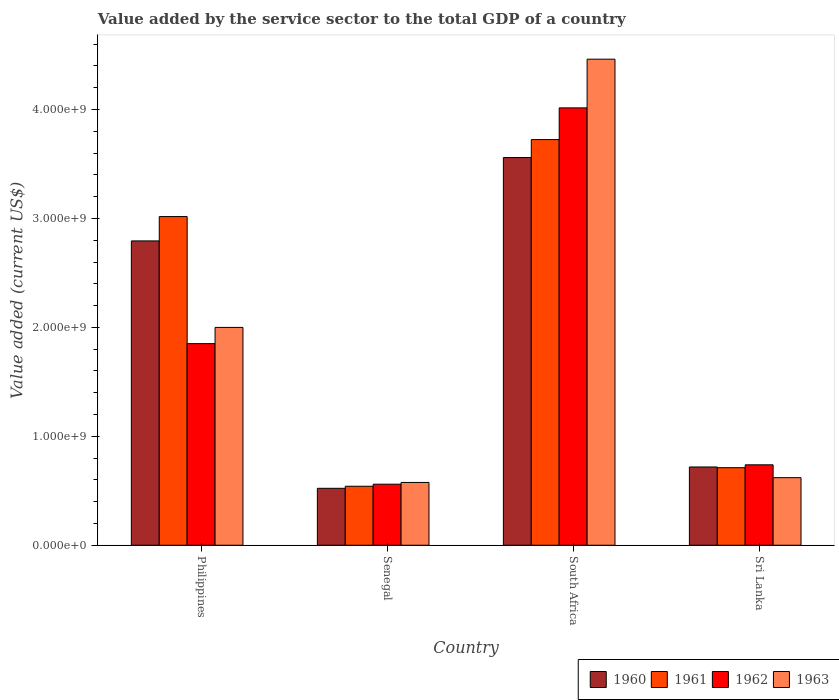How many different coloured bars are there?
Your response must be concise. 4. How many groups of bars are there?
Provide a short and direct response. 4. Are the number of bars on each tick of the X-axis equal?
Offer a very short reply. Yes. How many bars are there on the 3rd tick from the left?
Make the answer very short. 4. How many bars are there on the 4th tick from the right?
Offer a terse response. 4. What is the label of the 2nd group of bars from the left?
Provide a succinct answer. Senegal. What is the value added by the service sector to the total GDP in 1961 in Senegal?
Provide a succinct answer. 5.42e+08. Across all countries, what is the maximum value added by the service sector to the total GDP in 1960?
Ensure brevity in your answer.  3.56e+09. Across all countries, what is the minimum value added by the service sector to the total GDP in 1963?
Ensure brevity in your answer.  5.76e+08. In which country was the value added by the service sector to the total GDP in 1961 maximum?
Offer a terse response. South Africa. In which country was the value added by the service sector to the total GDP in 1960 minimum?
Offer a very short reply. Senegal. What is the total value added by the service sector to the total GDP in 1961 in the graph?
Provide a short and direct response. 7.99e+09. What is the difference between the value added by the service sector to the total GDP in 1963 in Philippines and that in Sri Lanka?
Provide a succinct answer. 1.38e+09. What is the difference between the value added by the service sector to the total GDP in 1962 in Sri Lanka and the value added by the service sector to the total GDP in 1961 in Philippines?
Your answer should be very brief. -2.28e+09. What is the average value added by the service sector to the total GDP in 1961 per country?
Keep it short and to the point. 2.00e+09. What is the difference between the value added by the service sector to the total GDP of/in 1961 and value added by the service sector to the total GDP of/in 1960 in Sri Lanka?
Your answer should be compact. -6.51e+06. In how many countries, is the value added by the service sector to the total GDP in 1963 greater than 3000000000 US$?
Provide a short and direct response. 1. What is the ratio of the value added by the service sector to the total GDP in 1960 in Philippines to that in South Africa?
Your answer should be compact. 0.78. Is the value added by the service sector to the total GDP in 1962 in Philippines less than that in South Africa?
Offer a very short reply. Yes. Is the difference between the value added by the service sector to the total GDP in 1961 in Senegal and South Africa greater than the difference between the value added by the service sector to the total GDP in 1960 in Senegal and South Africa?
Your response must be concise. No. What is the difference between the highest and the second highest value added by the service sector to the total GDP in 1961?
Ensure brevity in your answer.  -2.31e+09. What is the difference between the highest and the lowest value added by the service sector to the total GDP in 1961?
Keep it short and to the point. 3.18e+09. In how many countries, is the value added by the service sector to the total GDP in 1963 greater than the average value added by the service sector to the total GDP in 1963 taken over all countries?
Give a very brief answer. 2. What does the 2nd bar from the right in Philippines represents?
Your answer should be compact. 1962. How many bars are there?
Ensure brevity in your answer.  16. Does the graph contain grids?
Offer a very short reply. No. How are the legend labels stacked?
Offer a terse response. Horizontal. What is the title of the graph?
Provide a succinct answer. Value added by the service sector to the total GDP of a country. Does "2000" appear as one of the legend labels in the graph?
Offer a terse response. No. What is the label or title of the X-axis?
Your answer should be very brief. Country. What is the label or title of the Y-axis?
Provide a short and direct response. Value added (current US$). What is the Value added (current US$) of 1960 in Philippines?
Offer a very short reply. 2.79e+09. What is the Value added (current US$) in 1961 in Philippines?
Ensure brevity in your answer.  3.02e+09. What is the Value added (current US$) of 1962 in Philippines?
Ensure brevity in your answer.  1.85e+09. What is the Value added (current US$) in 1963 in Philippines?
Your answer should be very brief. 2.00e+09. What is the Value added (current US$) of 1960 in Senegal?
Your response must be concise. 5.23e+08. What is the Value added (current US$) of 1961 in Senegal?
Offer a terse response. 5.42e+08. What is the Value added (current US$) of 1962 in Senegal?
Make the answer very short. 5.60e+08. What is the Value added (current US$) of 1963 in Senegal?
Your response must be concise. 5.76e+08. What is the Value added (current US$) of 1960 in South Africa?
Give a very brief answer. 3.56e+09. What is the Value added (current US$) of 1961 in South Africa?
Your answer should be very brief. 3.72e+09. What is the Value added (current US$) of 1962 in South Africa?
Your answer should be very brief. 4.01e+09. What is the Value added (current US$) in 1963 in South Africa?
Keep it short and to the point. 4.46e+09. What is the Value added (current US$) in 1960 in Sri Lanka?
Your answer should be very brief. 7.18e+08. What is the Value added (current US$) in 1961 in Sri Lanka?
Ensure brevity in your answer.  7.12e+08. What is the Value added (current US$) in 1962 in Sri Lanka?
Ensure brevity in your answer.  7.38e+08. What is the Value added (current US$) in 1963 in Sri Lanka?
Your answer should be compact. 6.20e+08. Across all countries, what is the maximum Value added (current US$) of 1960?
Offer a terse response. 3.56e+09. Across all countries, what is the maximum Value added (current US$) in 1961?
Provide a succinct answer. 3.72e+09. Across all countries, what is the maximum Value added (current US$) in 1962?
Give a very brief answer. 4.01e+09. Across all countries, what is the maximum Value added (current US$) in 1963?
Ensure brevity in your answer.  4.46e+09. Across all countries, what is the minimum Value added (current US$) in 1960?
Your answer should be very brief. 5.23e+08. Across all countries, what is the minimum Value added (current US$) of 1961?
Give a very brief answer. 5.42e+08. Across all countries, what is the minimum Value added (current US$) of 1962?
Your response must be concise. 5.60e+08. Across all countries, what is the minimum Value added (current US$) in 1963?
Offer a terse response. 5.76e+08. What is the total Value added (current US$) in 1960 in the graph?
Your answer should be very brief. 7.59e+09. What is the total Value added (current US$) of 1961 in the graph?
Provide a short and direct response. 7.99e+09. What is the total Value added (current US$) in 1962 in the graph?
Offer a very short reply. 7.16e+09. What is the total Value added (current US$) of 1963 in the graph?
Offer a very short reply. 7.66e+09. What is the difference between the Value added (current US$) of 1960 in Philippines and that in Senegal?
Provide a short and direct response. 2.27e+09. What is the difference between the Value added (current US$) of 1961 in Philippines and that in Senegal?
Keep it short and to the point. 2.48e+09. What is the difference between the Value added (current US$) of 1962 in Philippines and that in Senegal?
Make the answer very short. 1.29e+09. What is the difference between the Value added (current US$) of 1963 in Philippines and that in Senegal?
Offer a very short reply. 1.42e+09. What is the difference between the Value added (current US$) in 1960 in Philippines and that in South Africa?
Your response must be concise. -7.66e+08. What is the difference between the Value added (current US$) in 1961 in Philippines and that in South Africa?
Make the answer very short. -7.07e+08. What is the difference between the Value added (current US$) of 1962 in Philippines and that in South Africa?
Offer a very short reply. -2.16e+09. What is the difference between the Value added (current US$) of 1963 in Philippines and that in South Africa?
Ensure brevity in your answer.  -2.46e+09. What is the difference between the Value added (current US$) in 1960 in Philippines and that in Sri Lanka?
Provide a succinct answer. 2.08e+09. What is the difference between the Value added (current US$) of 1961 in Philippines and that in Sri Lanka?
Offer a terse response. 2.31e+09. What is the difference between the Value added (current US$) in 1962 in Philippines and that in Sri Lanka?
Offer a terse response. 1.11e+09. What is the difference between the Value added (current US$) of 1963 in Philippines and that in Sri Lanka?
Offer a terse response. 1.38e+09. What is the difference between the Value added (current US$) in 1960 in Senegal and that in South Africa?
Keep it short and to the point. -3.04e+09. What is the difference between the Value added (current US$) of 1961 in Senegal and that in South Africa?
Make the answer very short. -3.18e+09. What is the difference between the Value added (current US$) of 1962 in Senegal and that in South Africa?
Your answer should be compact. -3.45e+09. What is the difference between the Value added (current US$) in 1963 in Senegal and that in South Africa?
Your answer should be very brief. -3.89e+09. What is the difference between the Value added (current US$) of 1960 in Senegal and that in Sri Lanka?
Your answer should be very brief. -1.96e+08. What is the difference between the Value added (current US$) in 1961 in Senegal and that in Sri Lanka?
Your answer should be compact. -1.70e+08. What is the difference between the Value added (current US$) of 1962 in Senegal and that in Sri Lanka?
Offer a terse response. -1.78e+08. What is the difference between the Value added (current US$) in 1963 in Senegal and that in Sri Lanka?
Your answer should be very brief. -4.38e+07. What is the difference between the Value added (current US$) in 1960 in South Africa and that in Sri Lanka?
Your answer should be very brief. 2.84e+09. What is the difference between the Value added (current US$) of 1961 in South Africa and that in Sri Lanka?
Your response must be concise. 3.01e+09. What is the difference between the Value added (current US$) of 1962 in South Africa and that in Sri Lanka?
Your answer should be very brief. 3.28e+09. What is the difference between the Value added (current US$) of 1963 in South Africa and that in Sri Lanka?
Keep it short and to the point. 3.84e+09. What is the difference between the Value added (current US$) of 1960 in Philippines and the Value added (current US$) of 1961 in Senegal?
Give a very brief answer. 2.25e+09. What is the difference between the Value added (current US$) in 1960 in Philippines and the Value added (current US$) in 1962 in Senegal?
Your response must be concise. 2.23e+09. What is the difference between the Value added (current US$) of 1960 in Philippines and the Value added (current US$) of 1963 in Senegal?
Your answer should be very brief. 2.22e+09. What is the difference between the Value added (current US$) of 1961 in Philippines and the Value added (current US$) of 1962 in Senegal?
Ensure brevity in your answer.  2.46e+09. What is the difference between the Value added (current US$) of 1961 in Philippines and the Value added (current US$) of 1963 in Senegal?
Offer a terse response. 2.44e+09. What is the difference between the Value added (current US$) in 1962 in Philippines and the Value added (current US$) in 1963 in Senegal?
Ensure brevity in your answer.  1.27e+09. What is the difference between the Value added (current US$) of 1960 in Philippines and the Value added (current US$) of 1961 in South Africa?
Provide a short and direct response. -9.30e+08. What is the difference between the Value added (current US$) of 1960 in Philippines and the Value added (current US$) of 1962 in South Africa?
Provide a succinct answer. -1.22e+09. What is the difference between the Value added (current US$) in 1960 in Philippines and the Value added (current US$) in 1963 in South Africa?
Provide a succinct answer. -1.67e+09. What is the difference between the Value added (current US$) of 1961 in Philippines and the Value added (current US$) of 1962 in South Africa?
Provide a short and direct response. -9.98e+08. What is the difference between the Value added (current US$) of 1961 in Philippines and the Value added (current US$) of 1963 in South Africa?
Your answer should be compact. -1.44e+09. What is the difference between the Value added (current US$) in 1962 in Philippines and the Value added (current US$) in 1963 in South Africa?
Your answer should be very brief. -2.61e+09. What is the difference between the Value added (current US$) of 1960 in Philippines and the Value added (current US$) of 1961 in Sri Lanka?
Give a very brief answer. 2.08e+09. What is the difference between the Value added (current US$) in 1960 in Philippines and the Value added (current US$) in 1962 in Sri Lanka?
Give a very brief answer. 2.06e+09. What is the difference between the Value added (current US$) in 1960 in Philippines and the Value added (current US$) in 1963 in Sri Lanka?
Provide a short and direct response. 2.17e+09. What is the difference between the Value added (current US$) of 1961 in Philippines and the Value added (current US$) of 1962 in Sri Lanka?
Your response must be concise. 2.28e+09. What is the difference between the Value added (current US$) of 1961 in Philippines and the Value added (current US$) of 1963 in Sri Lanka?
Ensure brevity in your answer.  2.40e+09. What is the difference between the Value added (current US$) of 1962 in Philippines and the Value added (current US$) of 1963 in Sri Lanka?
Make the answer very short. 1.23e+09. What is the difference between the Value added (current US$) of 1960 in Senegal and the Value added (current US$) of 1961 in South Africa?
Ensure brevity in your answer.  -3.20e+09. What is the difference between the Value added (current US$) in 1960 in Senegal and the Value added (current US$) in 1962 in South Africa?
Offer a terse response. -3.49e+09. What is the difference between the Value added (current US$) in 1960 in Senegal and the Value added (current US$) in 1963 in South Africa?
Offer a very short reply. -3.94e+09. What is the difference between the Value added (current US$) of 1961 in Senegal and the Value added (current US$) of 1962 in South Africa?
Keep it short and to the point. -3.47e+09. What is the difference between the Value added (current US$) of 1961 in Senegal and the Value added (current US$) of 1963 in South Africa?
Provide a succinct answer. -3.92e+09. What is the difference between the Value added (current US$) of 1962 in Senegal and the Value added (current US$) of 1963 in South Africa?
Keep it short and to the point. -3.90e+09. What is the difference between the Value added (current US$) in 1960 in Senegal and the Value added (current US$) in 1961 in Sri Lanka?
Give a very brief answer. -1.89e+08. What is the difference between the Value added (current US$) in 1960 in Senegal and the Value added (current US$) in 1962 in Sri Lanka?
Give a very brief answer. -2.16e+08. What is the difference between the Value added (current US$) of 1960 in Senegal and the Value added (current US$) of 1963 in Sri Lanka?
Offer a very short reply. -9.75e+07. What is the difference between the Value added (current US$) of 1961 in Senegal and the Value added (current US$) of 1962 in Sri Lanka?
Your answer should be compact. -1.97e+08. What is the difference between the Value added (current US$) in 1961 in Senegal and the Value added (current US$) in 1963 in Sri Lanka?
Ensure brevity in your answer.  -7.85e+07. What is the difference between the Value added (current US$) in 1962 in Senegal and the Value added (current US$) in 1963 in Sri Lanka?
Offer a very short reply. -5.98e+07. What is the difference between the Value added (current US$) of 1960 in South Africa and the Value added (current US$) of 1961 in Sri Lanka?
Offer a very short reply. 2.85e+09. What is the difference between the Value added (current US$) in 1960 in South Africa and the Value added (current US$) in 1962 in Sri Lanka?
Offer a very short reply. 2.82e+09. What is the difference between the Value added (current US$) of 1960 in South Africa and the Value added (current US$) of 1963 in Sri Lanka?
Ensure brevity in your answer.  2.94e+09. What is the difference between the Value added (current US$) in 1961 in South Africa and the Value added (current US$) in 1962 in Sri Lanka?
Your response must be concise. 2.99e+09. What is the difference between the Value added (current US$) in 1961 in South Africa and the Value added (current US$) in 1963 in Sri Lanka?
Your answer should be very brief. 3.10e+09. What is the difference between the Value added (current US$) of 1962 in South Africa and the Value added (current US$) of 1963 in Sri Lanka?
Provide a succinct answer. 3.39e+09. What is the average Value added (current US$) of 1960 per country?
Ensure brevity in your answer.  1.90e+09. What is the average Value added (current US$) in 1961 per country?
Your response must be concise. 2.00e+09. What is the average Value added (current US$) of 1962 per country?
Offer a terse response. 1.79e+09. What is the average Value added (current US$) of 1963 per country?
Ensure brevity in your answer.  1.91e+09. What is the difference between the Value added (current US$) of 1960 and Value added (current US$) of 1961 in Philippines?
Provide a succinct answer. -2.24e+08. What is the difference between the Value added (current US$) of 1960 and Value added (current US$) of 1962 in Philippines?
Ensure brevity in your answer.  9.43e+08. What is the difference between the Value added (current US$) in 1960 and Value added (current US$) in 1963 in Philippines?
Your answer should be compact. 7.94e+08. What is the difference between the Value added (current US$) in 1961 and Value added (current US$) in 1962 in Philippines?
Offer a very short reply. 1.17e+09. What is the difference between the Value added (current US$) of 1961 and Value added (current US$) of 1963 in Philippines?
Ensure brevity in your answer.  1.02e+09. What is the difference between the Value added (current US$) in 1962 and Value added (current US$) in 1963 in Philippines?
Keep it short and to the point. -1.49e+08. What is the difference between the Value added (current US$) in 1960 and Value added (current US$) in 1961 in Senegal?
Make the answer very short. -1.90e+07. What is the difference between the Value added (current US$) of 1960 and Value added (current US$) of 1962 in Senegal?
Provide a succinct answer. -3.77e+07. What is the difference between the Value added (current US$) in 1960 and Value added (current US$) in 1963 in Senegal?
Your answer should be very brief. -5.38e+07. What is the difference between the Value added (current US$) of 1961 and Value added (current US$) of 1962 in Senegal?
Offer a very short reply. -1.87e+07. What is the difference between the Value added (current US$) in 1961 and Value added (current US$) in 1963 in Senegal?
Offer a very short reply. -3.48e+07. What is the difference between the Value added (current US$) in 1962 and Value added (current US$) in 1963 in Senegal?
Provide a succinct answer. -1.60e+07. What is the difference between the Value added (current US$) in 1960 and Value added (current US$) in 1961 in South Africa?
Provide a short and direct response. -1.65e+08. What is the difference between the Value added (current US$) of 1960 and Value added (current US$) of 1962 in South Africa?
Ensure brevity in your answer.  -4.56e+08. What is the difference between the Value added (current US$) in 1960 and Value added (current US$) in 1963 in South Africa?
Offer a very short reply. -9.03e+08. What is the difference between the Value added (current US$) of 1961 and Value added (current US$) of 1962 in South Africa?
Your answer should be compact. -2.91e+08. What is the difference between the Value added (current US$) in 1961 and Value added (current US$) in 1963 in South Africa?
Make the answer very short. -7.38e+08. What is the difference between the Value added (current US$) of 1962 and Value added (current US$) of 1963 in South Africa?
Keep it short and to the point. -4.47e+08. What is the difference between the Value added (current US$) in 1960 and Value added (current US$) in 1961 in Sri Lanka?
Ensure brevity in your answer.  6.51e+06. What is the difference between the Value added (current US$) in 1960 and Value added (current US$) in 1962 in Sri Lanka?
Ensure brevity in your answer.  -1.98e+07. What is the difference between the Value added (current US$) in 1960 and Value added (current US$) in 1963 in Sri Lanka?
Your answer should be compact. 9.83e+07. What is the difference between the Value added (current US$) in 1961 and Value added (current US$) in 1962 in Sri Lanka?
Offer a terse response. -2.63e+07. What is the difference between the Value added (current US$) in 1961 and Value added (current US$) in 1963 in Sri Lanka?
Offer a very short reply. 9.18e+07. What is the difference between the Value added (current US$) in 1962 and Value added (current US$) in 1963 in Sri Lanka?
Ensure brevity in your answer.  1.18e+08. What is the ratio of the Value added (current US$) in 1960 in Philippines to that in Senegal?
Offer a very short reply. 5.35. What is the ratio of the Value added (current US$) of 1961 in Philippines to that in Senegal?
Keep it short and to the point. 5.57. What is the ratio of the Value added (current US$) in 1962 in Philippines to that in Senegal?
Your answer should be very brief. 3.3. What is the ratio of the Value added (current US$) in 1963 in Philippines to that in Senegal?
Keep it short and to the point. 3.47. What is the ratio of the Value added (current US$) in 1960 in Philippines to that in South Africa?
Ensure brevity in your answer.  0.78. What is the ratio of the Value added (current US$) in 1961 in Philippines to that in South Africa?
Provide a succinct answer. 0.81. What is the ratio of the Value added (current US$) in 1962 in Philippines to that in South Africa?
Offer a terse response. 0.46. What is the ratio of the Value added (current US$) of 1963 in Philippines to that in South Africa?
Your answer should be very brief. 0.45. What is the ratio of the Value added (current US$) of 1960 in Philippines to that in Sri Lanka?
Provide a succinct answer. 3.89. What is the ratio of the Value added (current US$) in 1961 in Philippines to that in Sri Lanka?
Make the answer very short. 4.24. What is the ratio of the Value added (current US$) in 1962 in Philippines to that in Sri Lanka?
Your answer should be compact. 2.51. What is the ratio of the Value added (current US$) in 1963 in Philippines to that in Sri Lanka?
Ensure brevity in your answer.  3.22. What is the ratio of the Value added (current US$) in 1960 in Senegal to that in South Africa?
Your answer should be compact. 0.15. What is the ratio of the Value added (current US$) in 1961 in Senegal to that in South Africa?
Make the answer very short. 0.15. What is the ratio of the Value added (current US$) of 1962 in Senegal to that in South Africa?
Provide a short and direct response. 0.14. What is the ratio of the Value added (current US$) of 1963 in Senegal to that in South Africa?
Provide a short and direct response. 0.13. What is the ratio of the Value added (current US$) of 1960 in Senegal to that in Sri Lanka?
Provide a succinct answer. 0.73. What is the ratio of the Value added (current US$) in 1961 in Senegal to that in Sri Lanka?
Keep it short and to the point. 0.76. What is the ratio of the Value added (current US$) of 1962 in Senegal to that in Sri Lanka?
Your answer should be compact. 0.76. What is the ratio of the Value added (current US$) in 1963 in Senegal to that in Sri Lanka?
Give a very brief answer. 0.93. What is the ratio of the Value added (current US$) of 1960 in South Africa to that in Sri Lanka?
Offer a very short reply. 4.95. What is the ratio of the Value added (current US$) of 1961 in South Africa to that in Sri Lanka?
Offer a terse response. 5.23. What is the ratio of the Value added (current US$) in 1962 in South Africa to that in Sri Lanka?
Your answer should be very brief. 5.44. What is the ratio of the Value added (current US$) in 1963 in South Africa to that in Sri Lanka?
Offer a very short reply. 7.19. What is the difference between the highest and the second highest Value added (current US$) of 1960?
Give a very brief answer. 7.66e+08. What is the difference between the highest and the second highest Value added (current US$) of 1961?
Offer a terse response. 7.07e+08. What is the difference between the highest and the second highest Value added (current US$) in 1962?
Your answer should be very brief. 2.16e+09. What is the difference between the highest and the second highest Value added (current US$) of 1963?
Keep it short and to the point. 2.46e+09. What is the difference between the highest and the lowest Value added (current US$) in 1960?
Provide a succinct answer. 3.04e+09. What is the difference between the highest and the lowest Value added (current US$) in 1961?
Keep it short and to the point. 3.18e+09. What is the difference between the highest and the lowest Value added (current US$) of 1962?
Provide a succinct answer. 3.45e+09. What is the difference between the highest and the lowest Value added (current US$) in 1963?
Keep it short and to the point. 3.89e+09. 